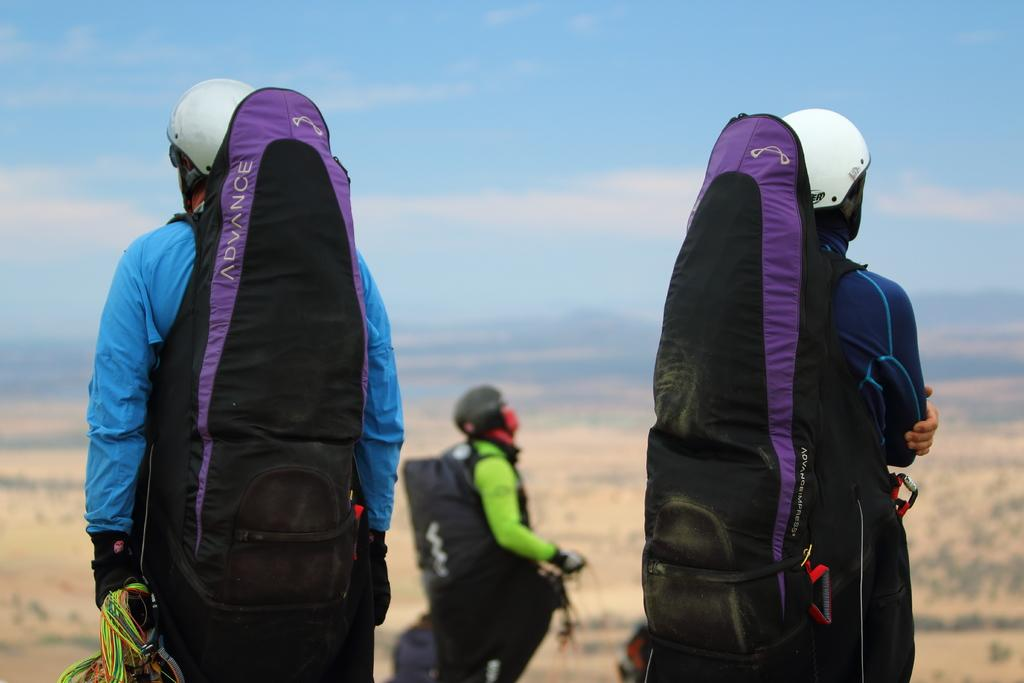How many men are in the image? There are three men in the image. What are the men wearing on their bodies? The men are wearing bags and ropes. What is the color of the sky in the image? The sky is blue in the image. Are there any clouds in the sky? Yes, the sky is cloudy in the image. How many tomatoes are hanging from the branch in the image? There is no branch or tomatoes present in the image. How long does it take for the men to complete their task in the image? The image does not provide information about the men's task or the time it takes to complete it. 